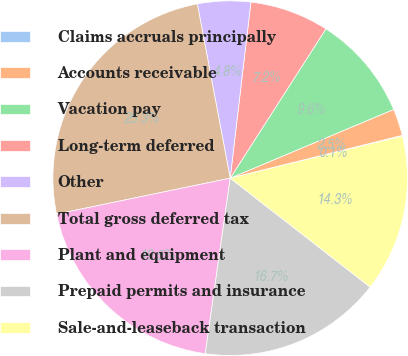Convert chart. <chart><loc_0><loc_0><loc_500><loc_500><pie_chart><fcel>Claims accruals principally<fcel>Accounts receivable<fcel>Vacation pay<fcel>Long-term deferred<fcel>Other<fcel>Total gross deferred tax<fcel>Plant and equipment<fcel>Prepaid permits and insurance<fcel>Sale-and-leaseback transaction<nl><fcel>0.07%<fcel>2.45%<fcel>9.59%<fcel>7.21%<fcel>4.83%<fcel>25.28%<fcel>19.5%<fcel>16.72%<fcel>14.34%<nl></chart> 